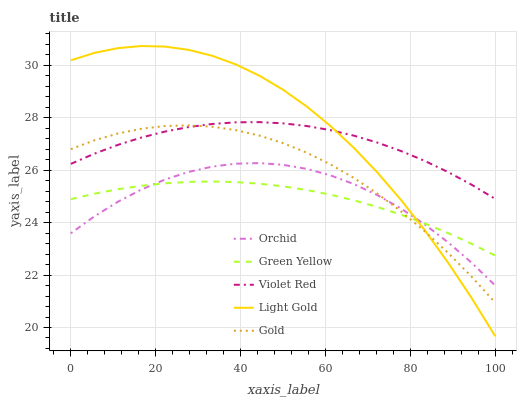Does Light Gold have the minimum area under the curve?
Answer yes or no. No. Does Green Yellow have the maximum area under the curve?
Answer yes or no. No. Is Light Gold the smoothest?
Answer yes or no. No. Is Green Yellow the roughest?
Answer yes or no. No. Does Green Yellow have the lowest value?
Answer yes or no. No. Does Green Yellow have the highest value?
Answer yes or no. No. Is Orchid less than Violet Red?
Answer yes or no. Yes. Is Violet Red greater than Green Yellow?
Answer yes or no. Yes. Does Orchid intersect Violet Red?
Answer yes or no. No. 